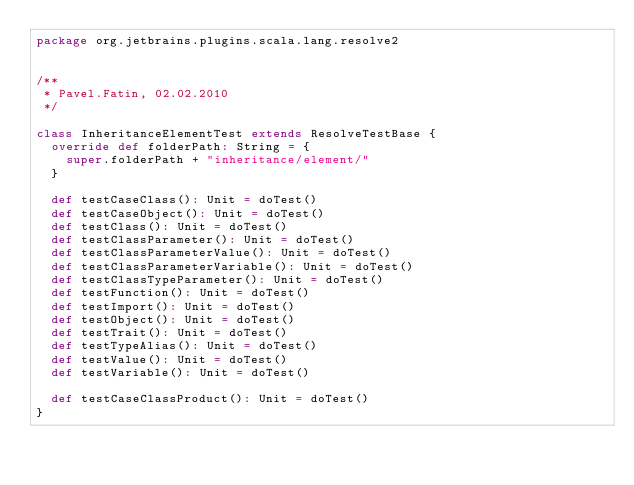<code> <loc_0><loc_0><loc_500><loc_500><_Scala_>package org.jetbrains.plugins.scala.lang.resolve2


/**
 * Pavel.Fatin, 02.02.2010
 */

class InheritanceElementTest extends ResolveTestBase {
  override def folderPath: String = {
    super.folderPath + "inheritance/element/"
  }

  def testCaseClass(): Unit = doTest()
  def testCaseObject(): Unit = doTest()
  def testClass(): Unit = doTest()
  def testClassParameter(): Unit = doTest()
  def testClassParameterValue(): Unit = doTest()
  def testClassParameterVariable(): Unit = doTest()
  def testClassTypeParameter(): Unit = doTest()
  def testFunction(): Unit = doTest()
  def testImport(): Unit = doTest()
  def testObject(): Unit = doTest()
  def testTrait(): Unit = doTest()
  def testTypeAlias(): Unit = doTest()
  def testValue(): Unit = doTest()
  def testVariable(): Unit = doTest()

  def testCaseClassProduct(): Unit = doTest()
}</code> 